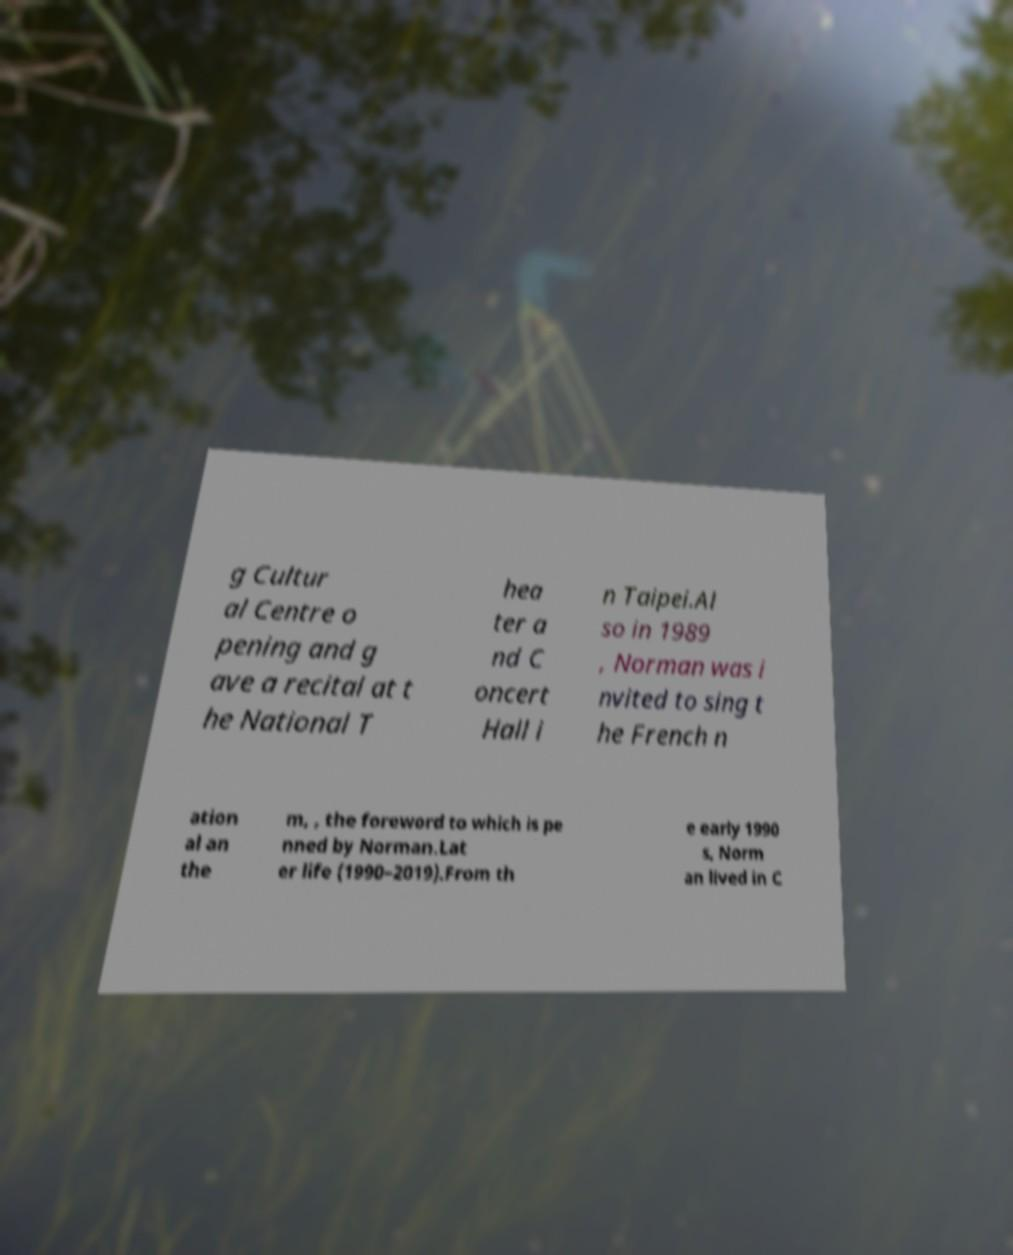Could you assist in decoding the text presented in this image and type it out clearly? g Cultur al Centre o pening and g ave a recital at t he National T hea ter a nd C oncert Hall i n Taipei.Al so in 1989 , Norman was i nvited to sing t he French n ation al an the m, , the foreword to which is pe nned by Norman.Lat er life (1990–2019).From th e early 1990 s, Norm an lived in C 